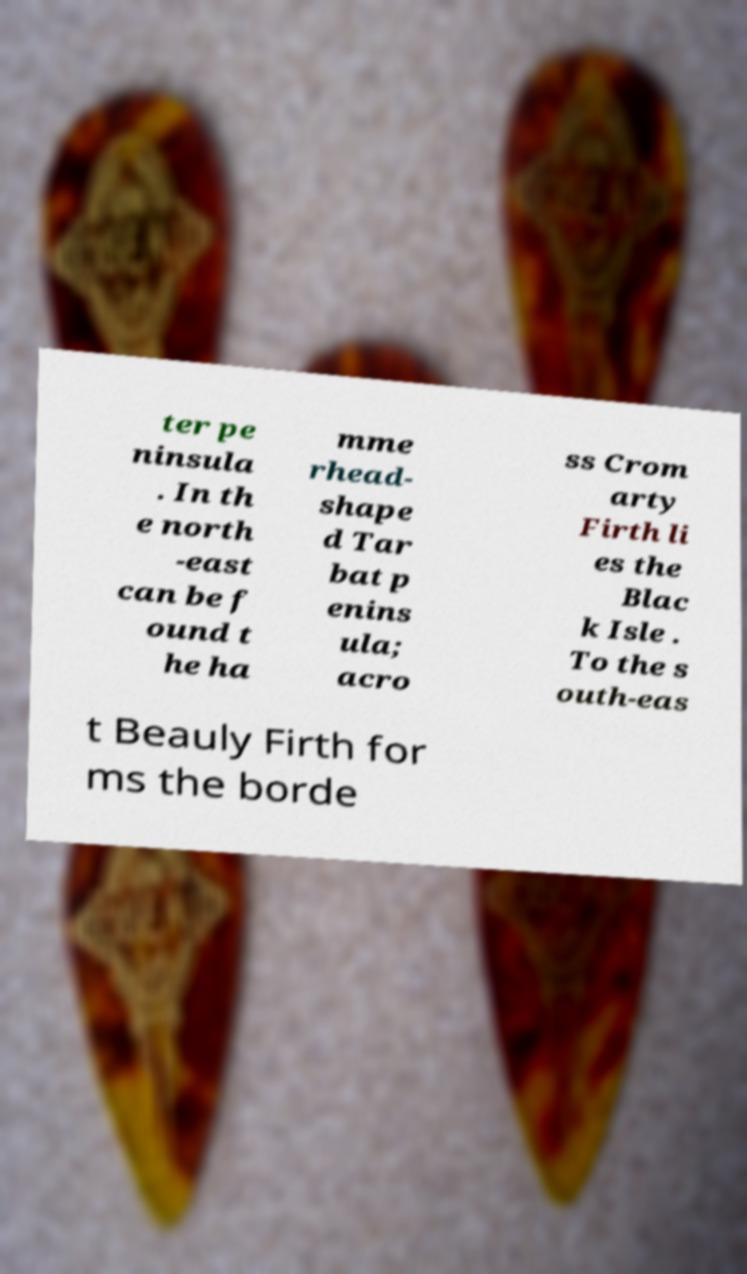Can you read and provide the text displayed in the image?This photo seems to have some interesting text. Can you extract and type it out for me? ter pe ninsula . In th e north -east can be f ound t he ha mme rhead- shape d Tar bat p enins ula; acro ss Crom arty Firth li es the Blac k Isle . To the s outh-eas t Beauly Firth for ms the borde 